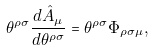Convert formula to latex. <formula><loc_0><loc_0><loc_500><loc_500>\theta ^ { \rho \sigma } \frac { d \hat { A } _ { \mu } } { d \theta ^ { \rho \sigma } } = \theta ^ { \rho \sigma } \Phi _ { \rho \sigma \mu } ,</formula> 